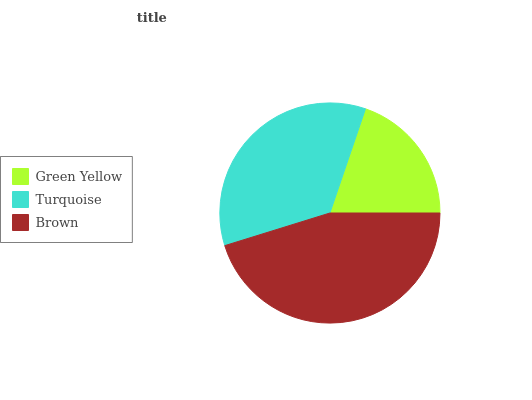Is Green Yellow the minimum?
Answer yes or no. Yes. Is Brown the maximum?
Answer yes or no. Yes. Is Turquoise the minimum?
Answer yes or no. No. Is Turquoise the maximum?
Answer yes or no. No. Is Turquoise greater than Green Yellow?
Answer yes or no. Yes. Is Green Yellow less than Turquoise?
Answer yes or no. Yes. Is Green Yellow greater than Turquoise?
Answer yes or no. No. Is Turquoise less than Green Yellow?
Answer yes or no. No. Is Turquoise the high median?
Answer yes or no. Yes. Is Turquoise the low median?
Answer yes or no. Yes. Is Brown the high median?
Answer yes or no. No. Is Brown the low median?
Answer yes or no. No. 